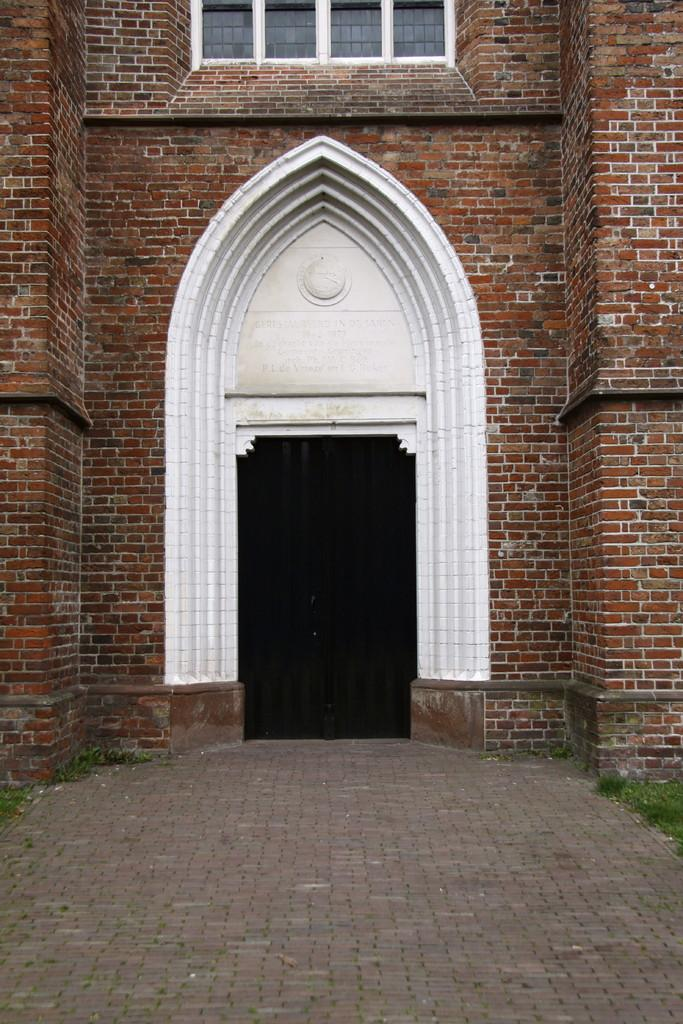What type of structure can be seen in the image? There is a wall with windows in the image. What architectural feature is present in the image? There is an arch in the image. What can be seen beneath the wall and arch? The ground is visible in the image. What type of vegetation is present in the image? There is grass in the image. How much money is being exchanged by the expert in the image? There is no money or expert present in the image. What type of material is the wall made of in the image? The provided facts do not specify the material of the wall, only that it has windows. 